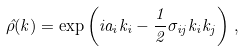Convert formula to latex. <formula><loc_0><loc_0><loc_500><loc_500>\hat { \rho } ( k ) = \exp \left ( i a _ { i } k _ { i } - \frac { 1 } { 2 } \sigma _ { i j } k _ { i } k _ { j } \right ) \, ,</formula> 